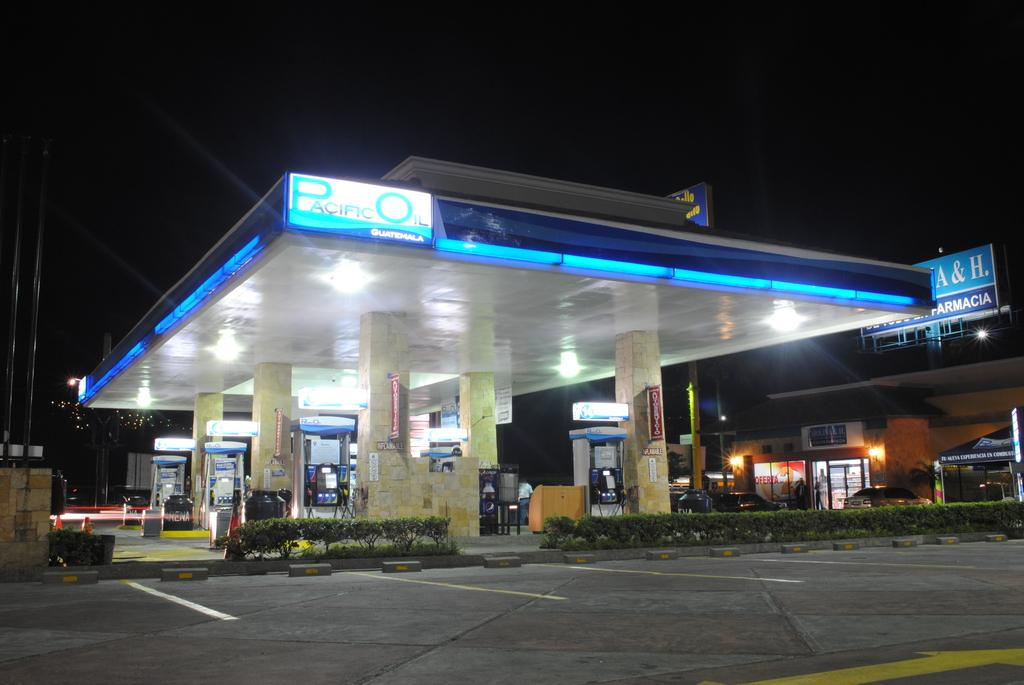What type of establishment is shown in the image? There is a fuel station in the image. What is located at the bottom of the image? There is a road at the bottom of the image. What can be seen in the middle of the image? There are plants in the middle of the image. What is visible at the top of the image? The sky is visible at the top of the image. What type of door can be seen in the image? There is no door present in the image. What is the cause of the thunder in the image? There is no thunder present in the image; it is a clear sky. 